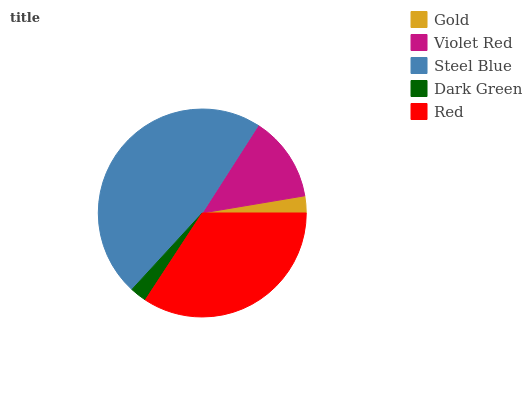Is Dark Green the minimum?
Answer yes or no. Yes. Is Steel Blue the maximum?
Answer yes or no. Yes. Is Violet Red the minimum?
Answer yes or no. No. Is Violet Red the maximum?
Answer yes or no. No. Is Violet Red greater than Gold?
Answer yes or no. Yes. Is Gold less than Violet Red?
Answer yes or no. Yes. Is Gold greater than Violet Red?
Answer yes or no. No. Is Violet Red less than Gold?
Answer yes or no. No. Is Violet Red the high median?
Answer yes or no. Yes. Is Violet Red the low median?
Answer yes or no. Yes. Is Steel Blue the high median?
Answer yes or no. No. Is Dark Green the low median?
Answer yes or no. No. 